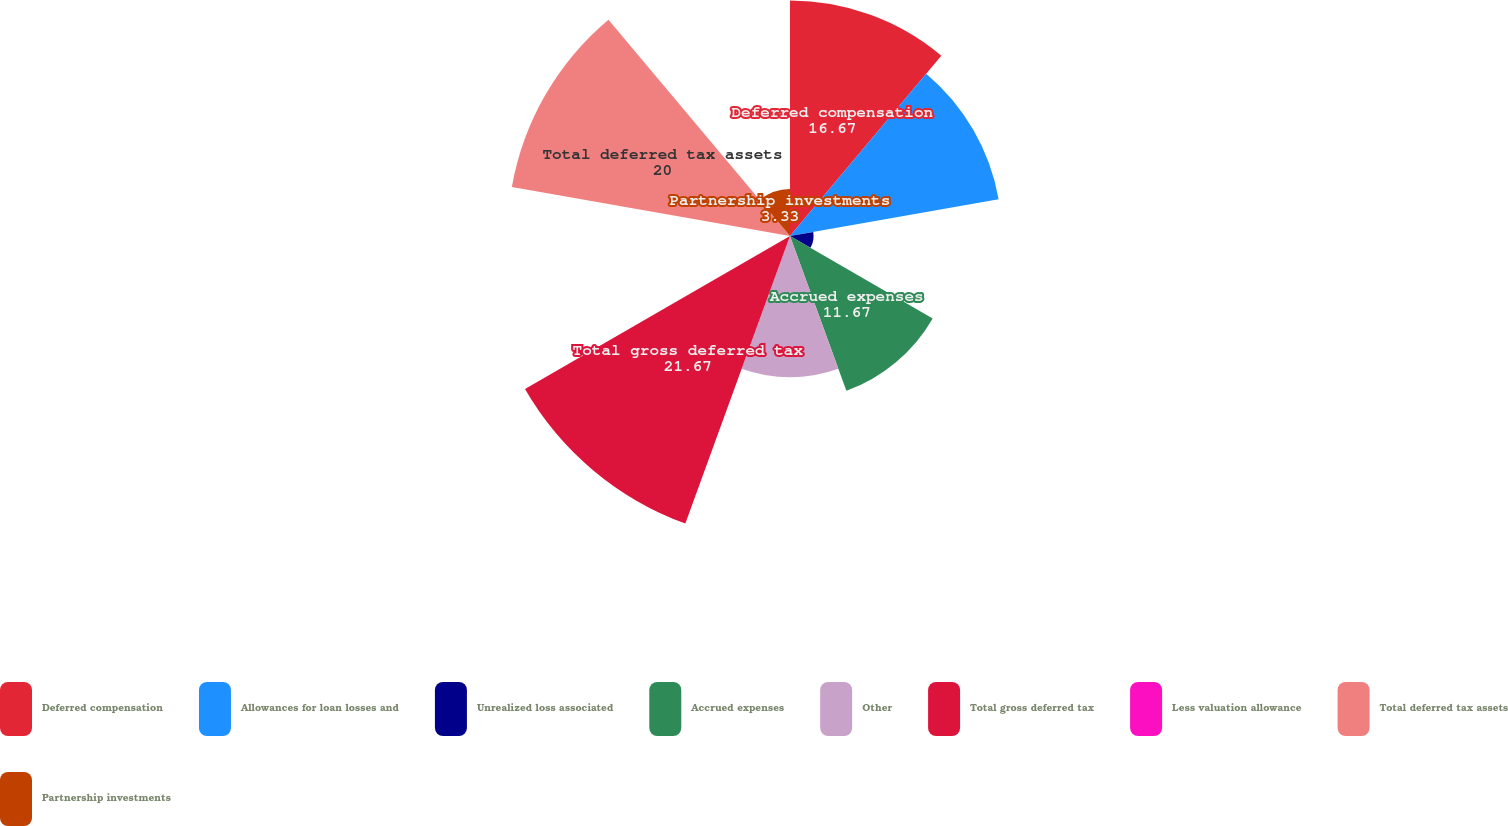Convert chart to OTSL. <chart><loc_0><loc_0><loc_500><loc_500><pie_chart><fcel>Deferred compensation<fcel>Allowances for loan losses and<fcel>Unrealized loss associated<fcel>Accrued expenses<fcel>Other<fcel>Total gross deferred tax<fcel>Less valuation allowance<fcel>Total deferred tax assets<fcel>Partnership investments<nl><fcel>16.67%<fcel>15.0%<fcel>1.67%<fcel>11.67%<fcel>10.0%<fcel>21.67%<fcel>0.0%<fcel>20.0%<fcel>3.33%<nl></chart> 